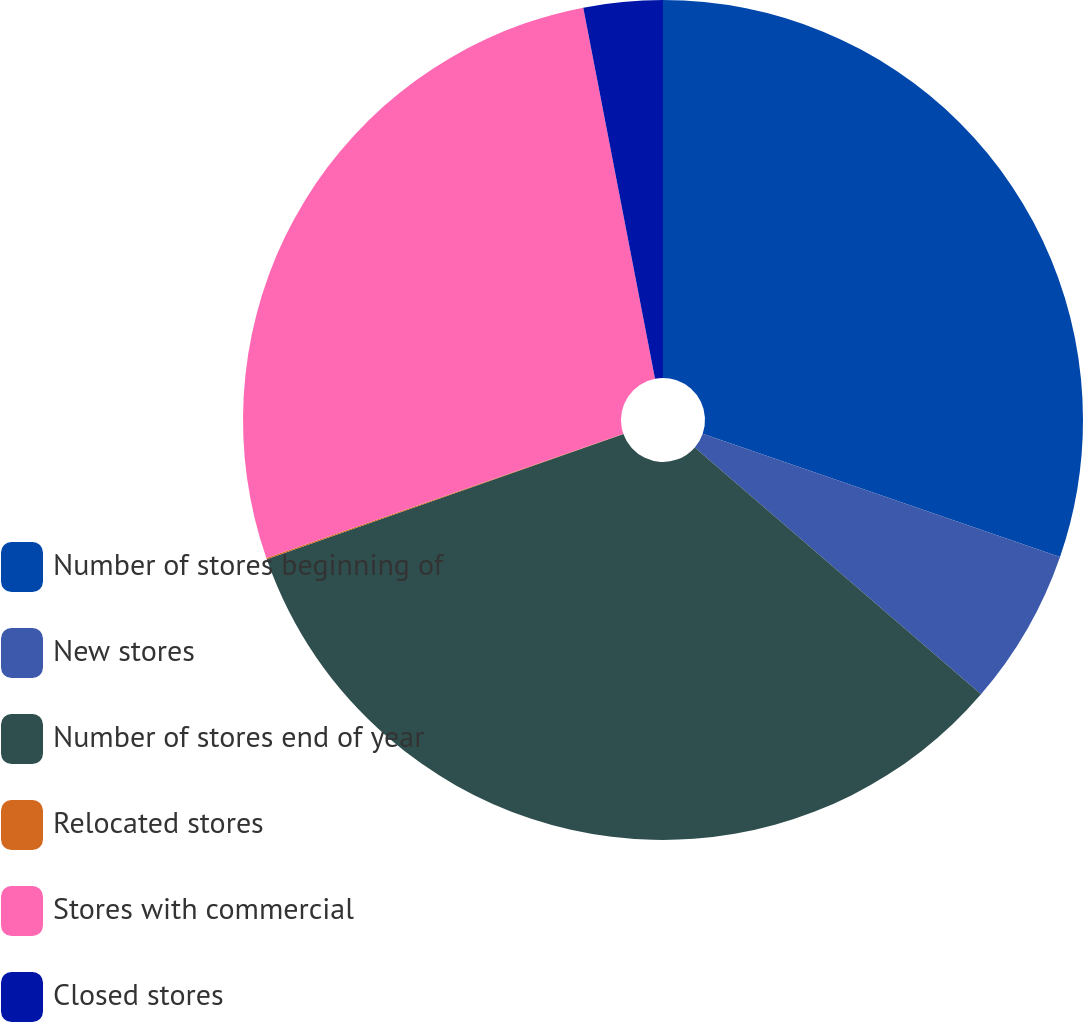<chart> <loc_0><loc_0><loc_500><loc_500><pie_chart><fcel>Number of stores beginning of<fcel>New stores<fcel>Number of stores end of year<fcel>Relocated stores<fcel>Stores with commercial<fcel>Closed stores<nl><fcel>30.29%<fcel>6.04%<fcel>33.29%<fcel>0.05%<fcel>27.29%<fcel>3.04%<nl></chart> 